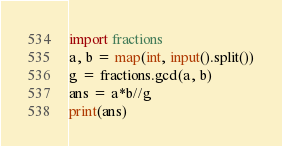Convert code to text. <code><loc_0><loc_0><loc_500><loc_500><_Python_>import fractions
a, b = map(int, input().split())
g = fractions.gcd(a, b)
ans = a*b//g
print(ans)</code> 